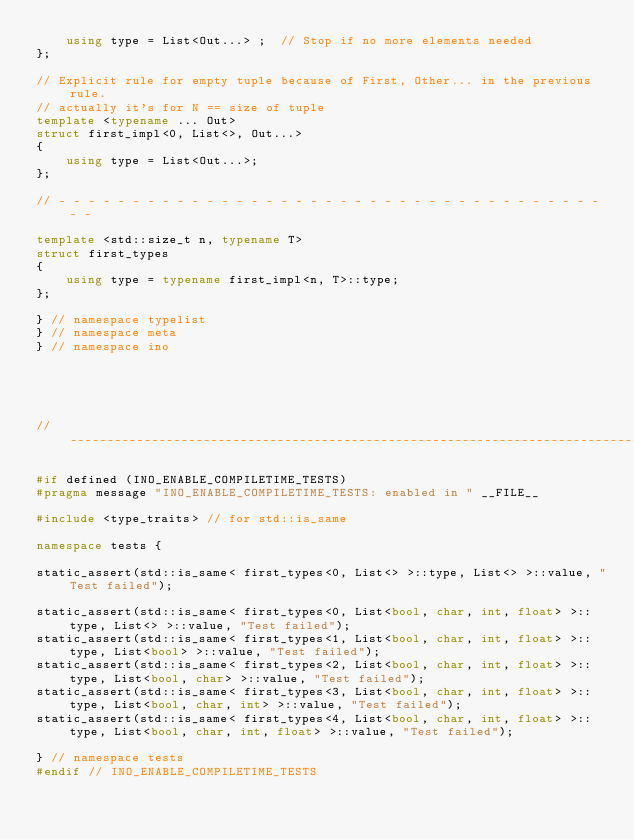<code> <loc_0><loc_0><loc_500><loc_500><_C++_>    using type = List<Out...> ;  // Stop if no more elements needed
};

// Explicit rule for empty tuple because of First, Other... in the previous rule.
// actually it's for N == size of tuple
template <typename ... Out>
struct first_impl<0, List<>, Out...>
{
    using type = List<Out...>;
};

// - - - - - - - - - - - - - - - - - - - - - - - - - - - - - - - - - - - - - - -

template <std::size_t n, typename T>
struct first_types
{
    using type = typename first_impl<n, T>::type;
};

} // namespace typelist
} // namespace meta
} // namespace ino





// -----------------------------------------------------------------------------

#if defined (INO_ENABLE_COMPILETIME_TESTS)
#pragma message "INO_ENABLE_COMPILETIME_TESTS: enabled in " __FILE__

#include <type_traits> // for std::is_same

namespace tests {

static_assert(std::is_same< first_types<0, List<> >::type, List<> >::value, "Test failed");

static_assert(std::is_same< first_types<0, List<bool, char, int, float> >::type, List<> >::value, "Test failed");
static_assert(std::is_same< first_types<1, List<bool, char, int, float> >::type, List<bool> >::value, "Test failed");
static_assert(std::is_same< first_types<2, List<bool, char, int, float> >::type, List<bool, char> >::value, "Test failed");
static_assert(std::is_same< first_types<3, List<bool, char, int, float> >::type, List<bool, char, int> >::value, "Test failed");
static_assert(std::is_same< first_types<4, List<bool, char, int, float> >::type, List<bool, char, int, float> >::value, "Test failed");

} // namespace tests
#endif // INO_ENABLE_COMPILETIME_TESTS
</code> 